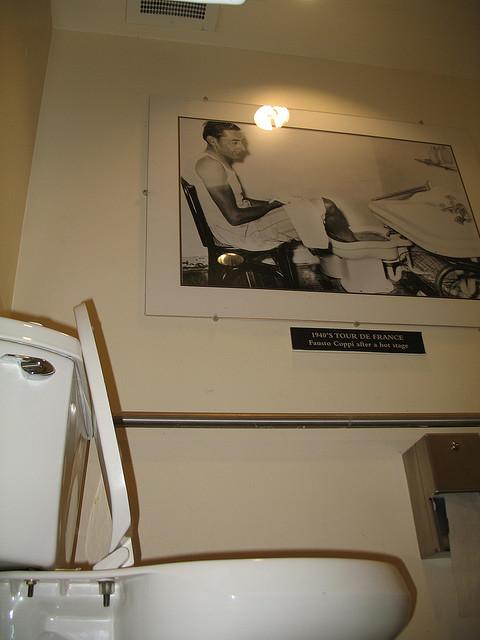Is the lid of the toilet up or down?
Keep it brief. Up. How would you flush this toilet?
Write a very short answer. With handle. Is this picture ironic?
Keep it brief. Yes. Is there a light on in this room?
Keep it brief. Yes. 